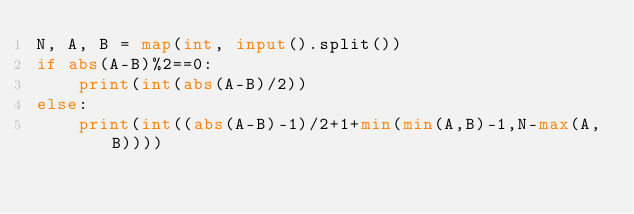Convert code to text. <code><loc_0><loc_0><loc_500><loc_500><_Python_>N, A, B = map(int, input().split())
if abs(A-B)%2==0:
    print(int(abs(A-B)/2))
else:
    print(int((abs(A-B)-1)/2+1+min(min(A,B)-1,N-max(A,B))))</code> 